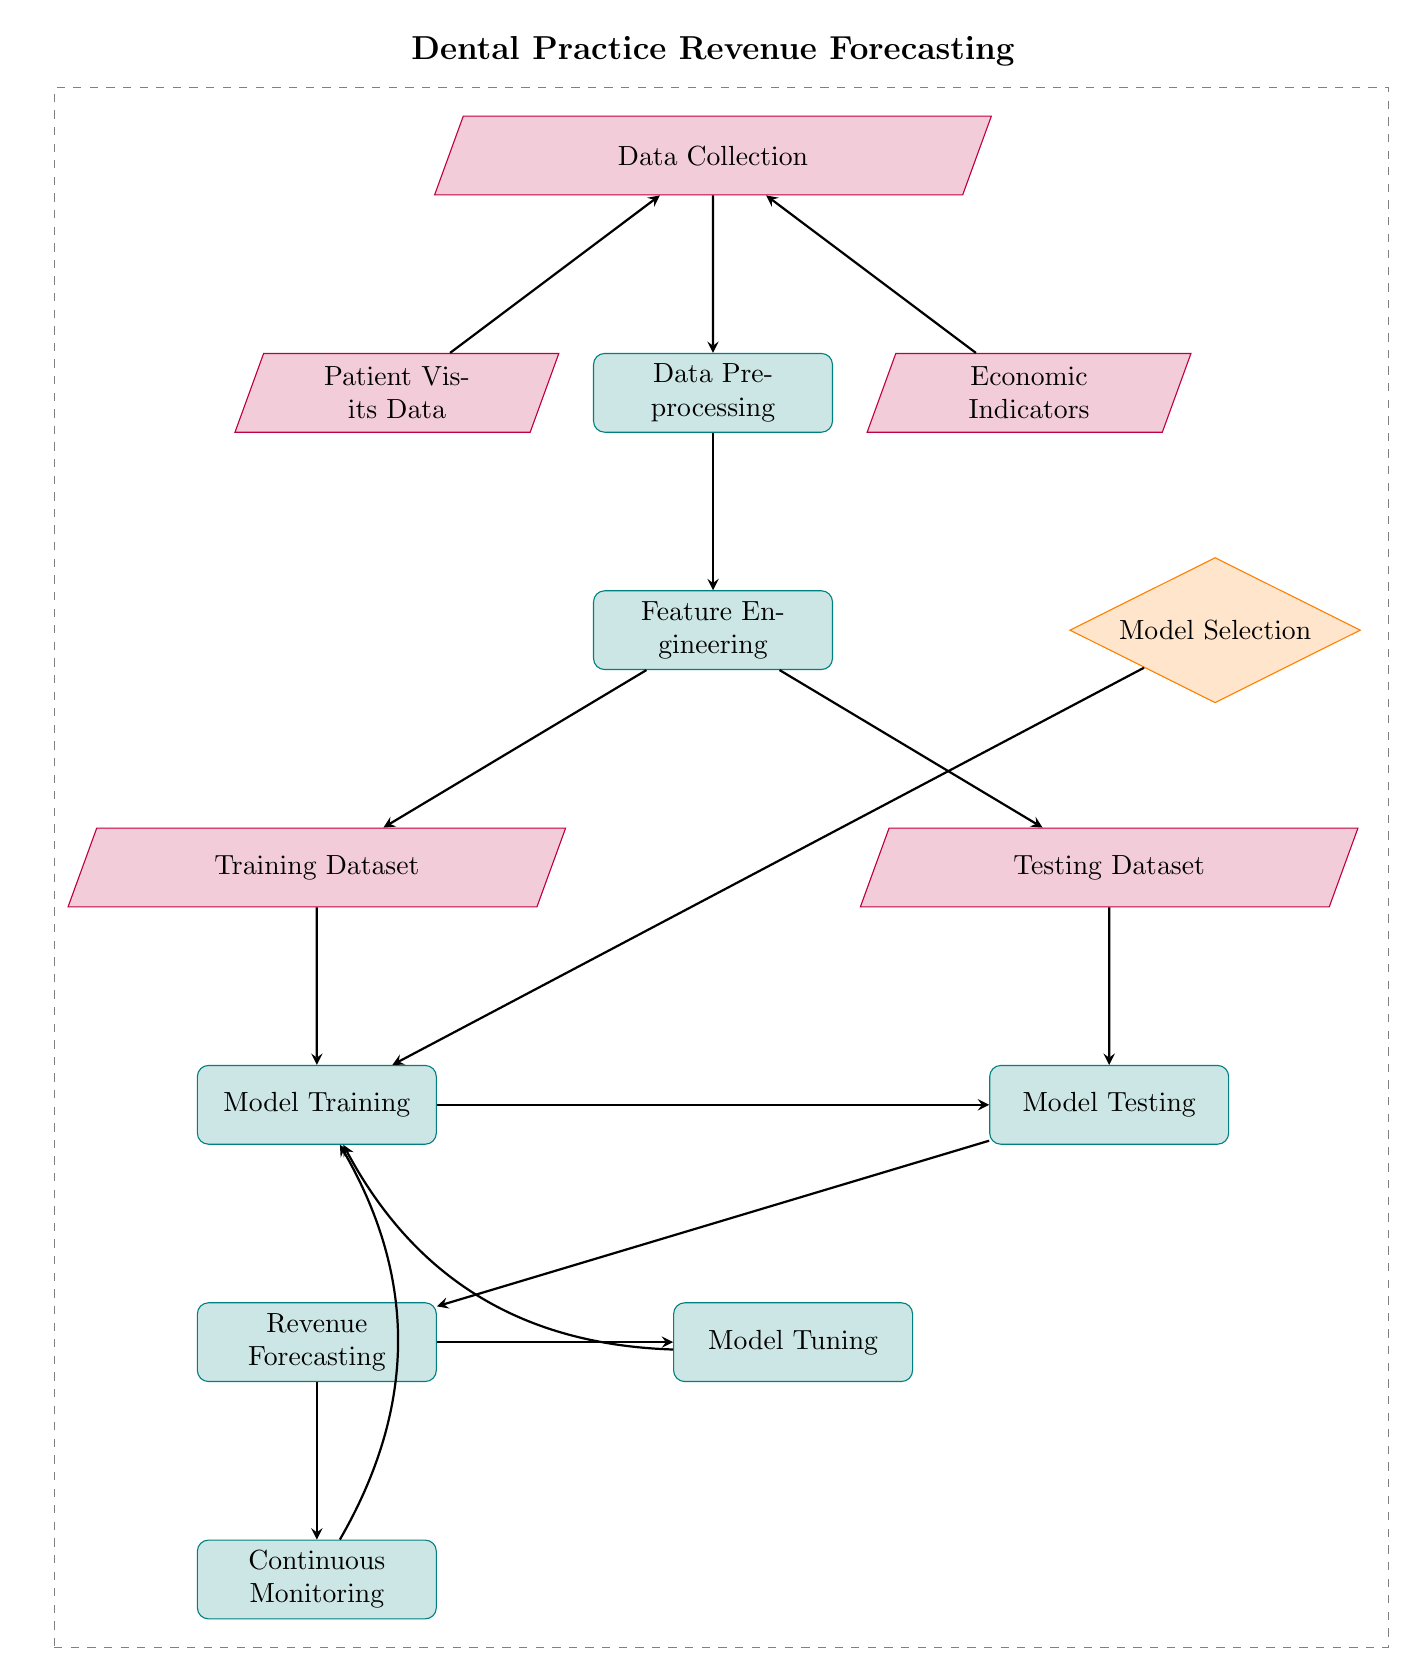What is the first step in the process? The diagram shows "Data Collection" as the node at the top, indicating that it is the initial step in the process.
Answer: Data Collection How many data nodes are there? The diagram shows three data nodes: "Patient Visits Data," "Economic Indicators," and "Training Dataset," and "Testing Dataset." So, there are four data nodes in total.
Answer: Four What is the relationship between "Data Preprocessing" and "Model Training"? "Data Preprocessing" leads directly to "Feature Engineering," which in turn leads to the "Training Dataset," providing the necessary data input for "Model Training."
Answer: Direct relationship Which node follows "Model Selection"? The node following "Model Selection" is "Model Training," indicating that after selecting a model, the next action is to train that model.
Answer: Model Training What processes are involved after forecasting revenue? After "Revenue Forecasting," the next processes are "Model Tuning" and "Continuous Monitoring.” Both are essential for refining the model and ensuring its performance.
Answer: Model Tuning and Continuous Monitoring Do the economic indicators contribute to the data collection? Yes, in the diagram, "Economic Indicators" is one of the inputs leading to "Data Collection," indicating that it contributes to the data.
Answer: Yes What is the output of the "Model Testing"? The output of "Model Testing" leads to "Revenue Forecasting," signifying that testing the model is a precursor to forecasting revenue.
Answer: Revenue Forecasting To which process does "Continuous Monitoring" link back? "Continuous Monitoring" links back to "Model Training," suggesting that the model is reassessed and trained based on continuous evaluations.
Answer: Model Training 